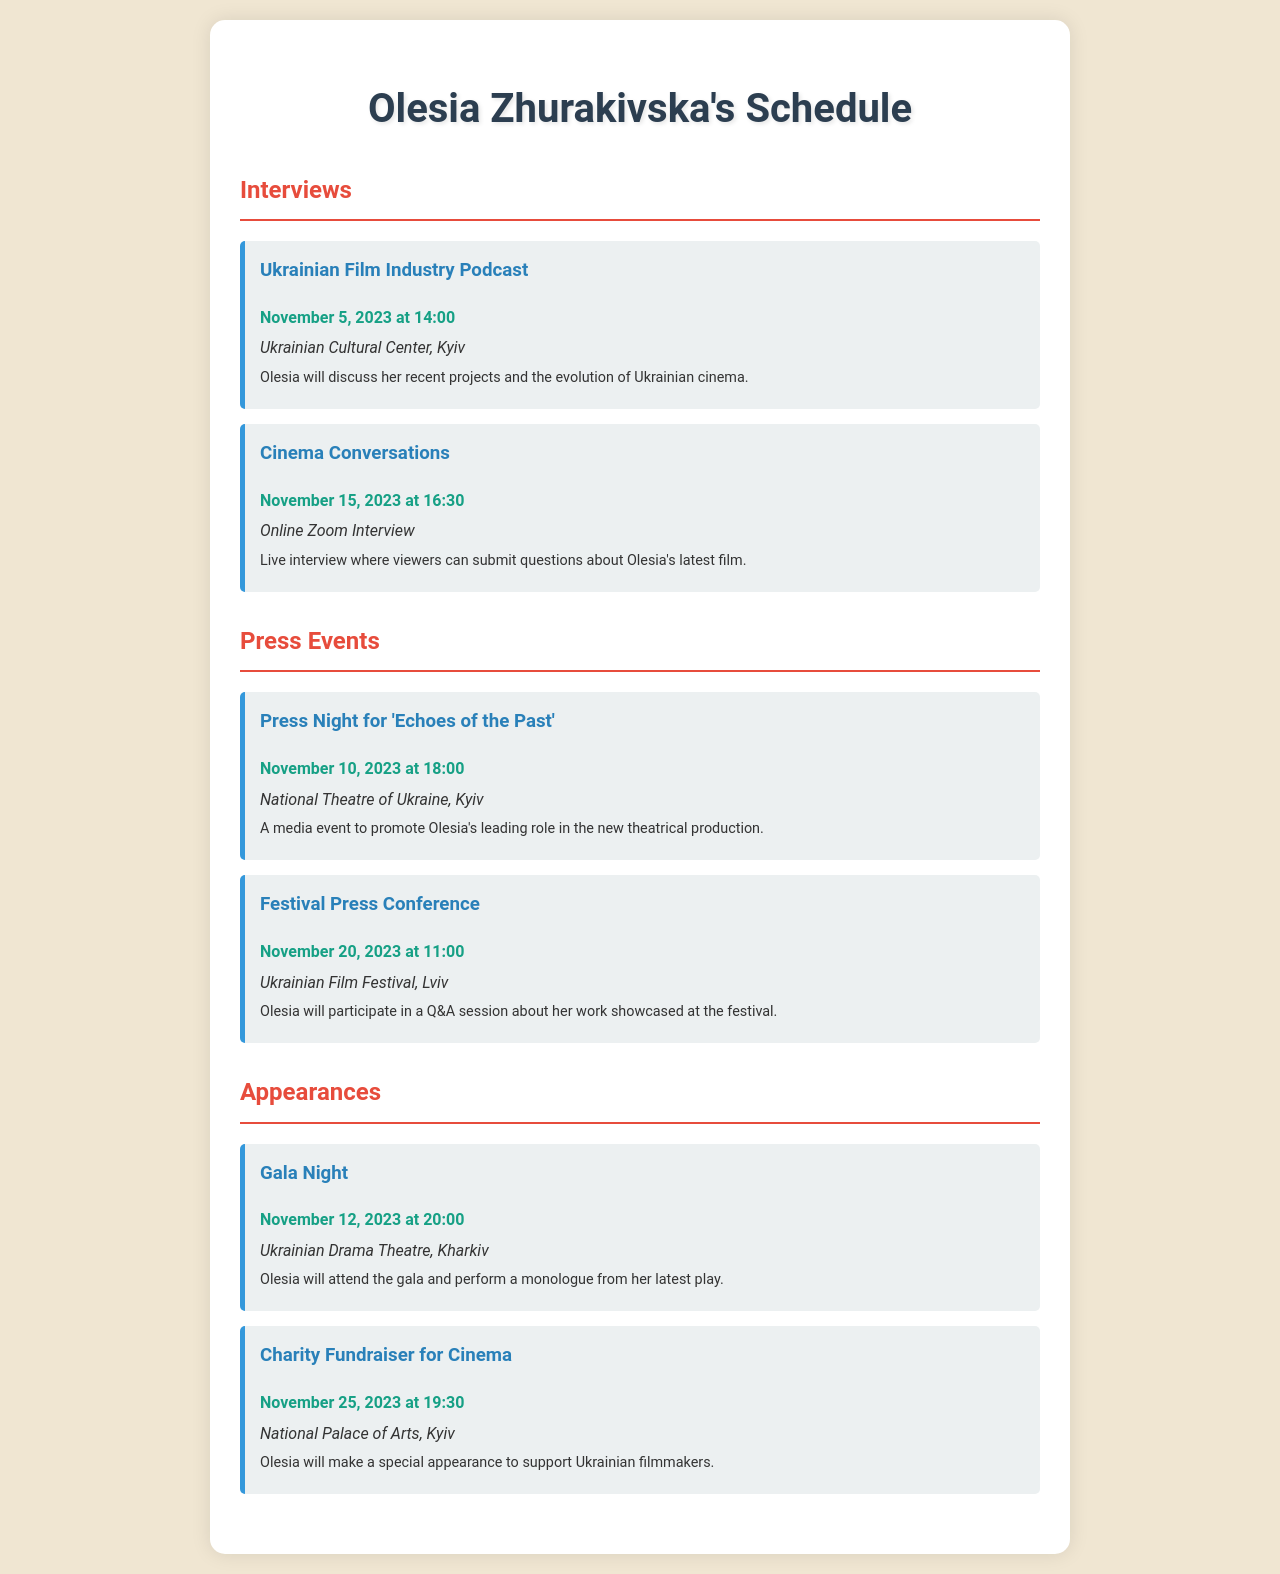What is the date of the Ukrainian Film Industry Podcast? The date is specified in the document under the Interviews section for the event titled "Ukrainian Film Industry Podcast."
Answer: November 5, 2023 Where will the Press Night for 'Echoes of the Past' take place? The venue for this event is mentioned in the document.
Answer: National Theatre of Ukraine, Kyiv What time is the charity fundraiser for cinema scheduled? The time is indicated in the document under the Appearances section for the event titled "Charity Fundraiser for Cinema."
Answer: 19:30 How many press events are listed in the document? A count of events under the Press Events section will give the answer.
Answer: 2 Which event takes place after the Gala Night? The document lists events in chronological order, and we can find the event after "Gala Night" by checking the schedule.
Answer: Charity Fundraiser for Cinema What type of event is the Cinema Conversations? The nature of the event is given in the document under the Interviews section.
Answer: Online Zoom Interview What will Olesia Zhurakivska perform at the Gala Night? The performance details are described in the appearance event titled "Gala Night."
Answer: A monologue from her latest play When is the Festival Press Conference scheduled? The schedule specifies the date for this press event.
Answer: November 20, 2023 